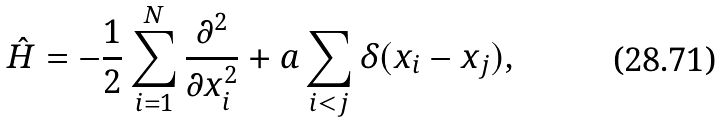<formula> <loc_0><loc_0><loc_500><loc_500>\hat { H } = - \frac { 1 } { 2 } \sum _ { i = 1 } ^ { N } \frac { \partial ^ { 2 } } { \partial x _ { i } ^ { 2 } } + a \sum _ { i < j } \delta ( x _ { i } - x _ { j } ) ,</formula> 